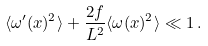Convert formula to latex. <formula><loc_0><loc_0><loc_500><loc_500>\langle \omega ^ { \prime } ( x ) ^ { 2 } \rangle + \frac { 2 f } { L ^ { 2 } } \langle \omega ( x ) ^ { 2 } \rangle \ll 1 \, .</formula> 